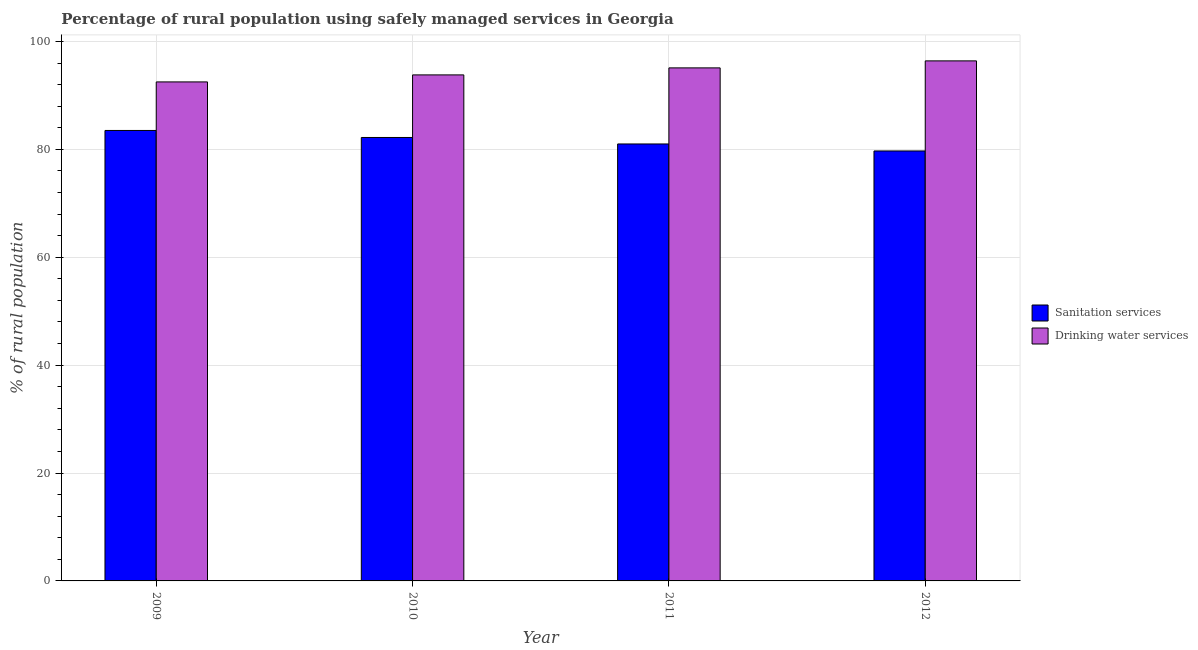How many different coloured bars are there?
Provide a short and direct response. 2. How many groups of bars are there?
Provide a short and direct response. 4. Are the number of bars per tick equal to the number of legend labels?
Give a very brief answer. Yes. Are the number of bars on each tick of the X-axis equal?
Make the answer very short. Yes. How many bars are there on the 1st tick from the left?
Your answer should be compact. 2. What is the label of the 4th group of bars from the left?
Keep it short and to the point. 2012. What is the percentage of rural population who used sanitation services in 2009?
Your answer should be very brief. 83.5. Across all years, what is the maximum percentage of rural population who used drinking water services?
Offer a terse response. 96.4. Across all years, what is the minimum percentage of rural population who used drinking water services?
Provide a succinct answer. 92.5. In which year was the percentage of rural population who used drinking water services maximum?
Your answer should be compact. 2012. What is the total percentage of rural population who used drinking water services in the graph?
Make the answer very short. 377.8. What is the difference between the percentage of rural population who used drinking water services in 2010 and that in 2011?
Give a very brief answer. -1.3. What is the difference between the percentage of rural population who used drinking water services in 2012 and the percentage of rural population who used sanitation services in 2009?
Provide a short and direct response. 3.9. What is the average percentage of rural population who used sanitation services per year?
Your answer should be very brief. 81.6. What is the ratio of the percentage of rural population who used drinking water services in 2010 to that in 2012?
Offer a very short reply. 0.97. Is the percentage of rural population who used drinking water services in 2010 less than that in 2012?
Ensure brevity in your answer.  Yes. Is the difference between the percentage of rural population who used drinking water services in 2010 and 2011 greater than the difference between the percentage of rural population who used sanitation services in 2010 and 2011?
Offer a terse response. No. What is the difference between the highest and the second highest percentage of rural population who used sanitation services?
Give a very brief answer. 1.3. What is the difference between the highest and the lowest percentage of rural population who used drinking water services?
Provide a succinct answer. 3.9. In how many years, is the percentage of rural population who used drinking water services greater than the average percentage of rural population who used drinking water services taken over all years?
Your answer should be compact. 2. What does the 1st bar from the left in 2010 represents?
Your response must be concise. Sanitation services. What does the 1st bar from the right in 2012 represents?
Make the answer very short. Drinking water services. Are all the bars in the graph horizontal?
Offer a terse response. No. Are the values on the major ticks of Y-axis written in scientific E-notation?
Make the answer very short. No. Does the graph contain any zero values?
Ensure brevity in your answer.  No. Does the graph contain grids?
Provide a short and direct response. Yes. How many legend labels are there?
Your answer should be compact. 2. What is the title of the graph?
Ensure brevity in your answer.  Percentage of rural population using safely managed services in Georgia. What is the label or title of the X-axis?
Your response must be concise. Year. What is the label or title of the Y-axis?
Provide a short and direct response. % of rural population. What is the % of rural population in Sanitation services in 2009?
Your answer should be very brief. 83.5. What is the % of rural population of Drinking water services in 2009?
Make the answer very short. 92.5. What is the % of rural population in Sanitation services in 2010?
Ensure brevity in your answer.  82.2. What is the % of rural population of Drinking water services in 2010?
Make the answer very short. 93.8. What is the % of rural population in Sanitation services in 2011?
Ensure brevity in your answer.  81. What is the % of rural population in Drinking water services in 2011?
Ensure brevity in your answer.  95.1. What is the % of rural population of Sanitation services in 2012?
Offer a very short reply. 79.7. What is the % of rural population of Drinking water services in 2012?
Keep it short and to the point. 96.4. Across all years, what is the maximum % of rural population in Sanitation services?
Provide a short and direct response. 83.5. Across all years, what is the maximum % of rural population in Drinking water services?
Offer a very short reply. 96.4. Across all years, what is the minimum % of rural population of Sanitation services?
Your answer should be compact. 79.7. Across all years, what is the minimum % of rural population in Drinking water services?
Keep it short and to the point. 92.5. What is the total % of rural population of Sanitation services in the graph?
Ensure brevity in your answer.  326.4. What is the total % of rural population in Drinking water services in the graph?
Your answer should be very brief. 377.8. What is the difference between the % of rural population in Sanitation services in 2009 and that in 2011?
Provide a short and direct response. 2.5. What is the difference between the % of rural population in Drinking water services in 2009 and that in 2011?
Provide a short and direct response. -2.6. What is the difference between the % of rural population of Drinking water services in 2009 and that in 2012?
Your response must be concise. -3.9. What is the difference between the % of rural population in Sanitation services in 2010 and that in 2011?
Provide a short and direct response. 1.2. What is the difference between the % of rural population of Drinking water services in 2010 and that in 2011?
Keep it short and to the point. -1.3. What is the difference between the % of rural population in Sanitation services in 2010 and that in 2012?
Provide a short and direct response. 2.5. What is the difference between the % of rural population in Drinking water services in 2011 and that in 2012?
Keep it short and to the point. -1.3. What is the difference between the % of rural population in Sanitation services in 2009 and the % of rural population in Drinking water services in 2010?
Your answer should be compact. -10.3. What is the difference between the % of rural population in Sanitation services in 2009 and the % of rural population in Drinking water services in 2011?
Your response must be concise. -11.6. What is the difference between the % of rural population of Sanitation services in 2011 and the % of rural population of Drinking water services in 2012?
Offer a terse response. -15.4. What is the average % of rural population of Sanitation services per year?
Provide a succinct answer. 81.6. What is the average % of rural population of Drinking water services per year?
Offer a very short reply. 94.45. In the year 2009, what is the difference between the % of rural population of Sanitation services and % of rural population of Drinking water services?
Provide a short and direct response. -9. In the year 2011, what is the difference between the % of rural population in Sanitation services and % of rural population in Drinking water services?
Your answer should be very brief. -14.1. In the year 2012, what is the difference between the % of rural population of Sanitation services and % of rural population of Drinking water services?
Your answer should be compact. -16.7. What is the ratio of the % of rural population of Sanitation services in 2009 to that in 2010?
Provide a short and direct response. 1.02. What is the ratio of the % of rural population of Drinking water services in 2009 to that in 2010?
Offer a terse response. 0.99. What is the ratio of the % of rural population of Sanitation services in 2009 to that in 2011?
Offer a very short reply. 1.03. What is the ratio of the % of rural population of Drinking water services in 2009 to that in 2011?
Provide a short and direct response. 0.97. What is the ratio of the % of rural population of Sanitation services in 2009 to that in 2012?
Offer a very short reply. 1.05. What is the ratio of the % of rural population of Drinking water services in 2009 to that in 2012?
Your answer should be very brief. 0.96. What is the ratio of the % of rural population in Sanitation services in 2010 to that in 2011?
Ensure brevity in your answer.  1.01. What is the ratio of the % of rural population of Drinking water services in 2010 to that in 2011?
Keep it short and to the point. 0.99. What is the ratio of the % of rural population in Sanitation services in 2010 to that in 2012?
Make the answer very short. 1.03. What is the ratio of the % of rural population in Drinking water services in 2010 to that in 2012?
Offer a very short reply. 0.97. What is the ratio of the % of rural population of Sanitation services in 2011 to that in 2012?
Your response must be concise. 1.02. What is the ratio of the % of rural population of Drinking water services in 2011 to that in 2012?
Offer a terse response. 0.99. What is the difference between the highest and the lowest % of rural population in Drinking water services?
Your response must be concise. 3.9. 